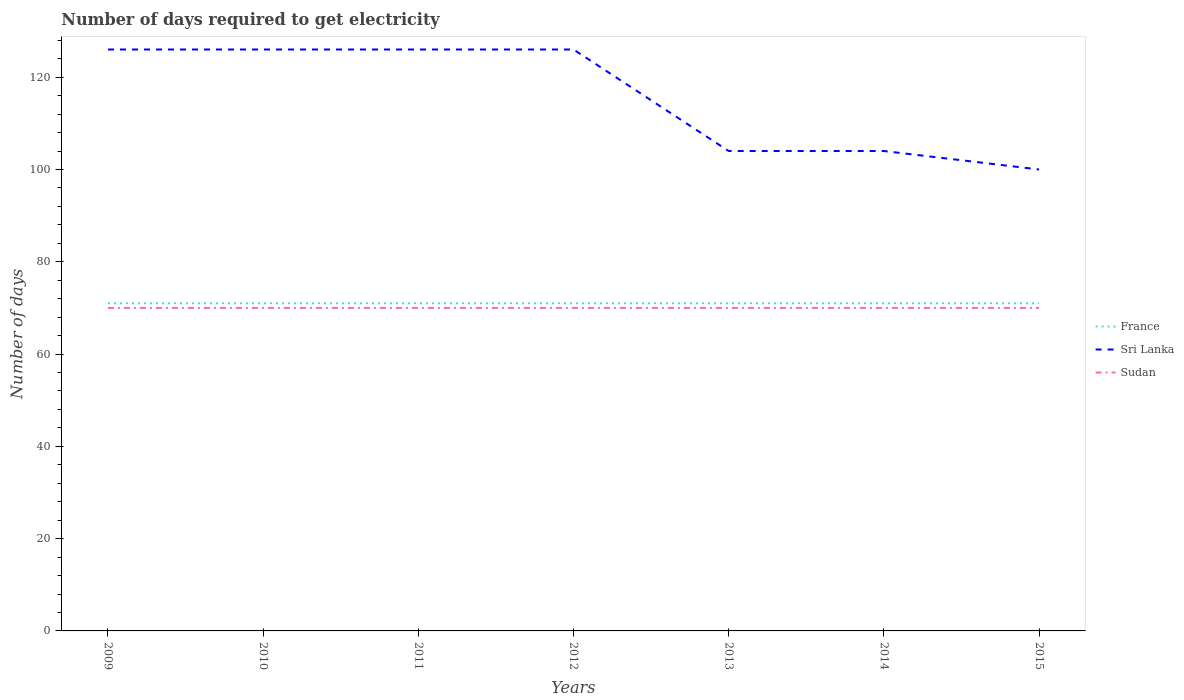How many different coloured lines are there?
Offer a very short reply. 3. Is the number of lines equal to the number of legend labels?
Your response must be concise. Yes. Across all years, what is the maximum number of days required to get electricity in in Sudan?
Your answer should be compact. 70. In which year was the number of days required to get electricity in in France maximum?
Provide a succinct answer. 2009. What is the total number of days required to get electricity in in Sri Lanka in the graph?
Give a very brief answer. 26. How many lines are there?
Offer a very short reply. 3. How many years are there in the graph?
Make the answer very short. 7. How many legend labels are there?
Provide a short and direct response. 3. What is the title of the graph?
Your answer should be compact. Number of days required to get electricity. Does "Bosnia and Herzegovina" appear as one of the legend labels in the graph?
Provide a short and direct response. No. What is the label or title of the Y-axis?
Make the answer very short. Number of days. What is the Number of days in France in 2009?
Your response must be concise. 71. What is the Number of days in Sri Lanka in 2009?
Your answer should be compact. 126. What is the Number of days in France in 2010?
Keep it short and to the point. 71. What is the Number of days of Sri Lanka in 2010?
Give a very brief answer. 126. What is the Number of days in Sudan in 2010?
Make the answer very short. 70. What is the Number of days in Sri Lanka in 2011?
Provide a short and direct response. 126. What is the Number of days of Sri Lanka in 2012?
Your answer should be compact. 126. What is the Number of days in Sudan in 2012?
Offer a terse response. 70. What is the Number of days in Sri Lanka in 2013?
Offer a terse response. 104. What is the Number of days in Sudan in 2013?
Offer a very short reply. 70. What is the Number of days in Sri Lanka in 2014?
Make the answer very short. 104. What is the Number of days in Sudan in 2014?
Your answer should be very brief. 70. What is the Number of days of Sri Lanka in 2015?
Your answer should be very brief. 100. Across all years, what is the maximum Number of days of France?
Your response must be concise. 71. Across all years, what is the maximum Number of days in Sri Lanka?
Provide a succinct answer. 126. Across all years, what is the minimum Number of days in France?
Provide a short and direct response. 71. What is the total Number of days in France in the graph?
Provide a succinct answer. 497. What is the total Number of days in Sri Lanka in the graph?
Provide a succinct answer. 812. What is the total Number of days in Sudan in the graph?
Provide a short and direct response. 490. What is the difference between the Number of days of Sri Lanka in 2009 and that in 2010?
Your answer should be very brief. 0. What is the difference between the Number of days in France in 2009 and that in 2011?
Offer a terse response. 0. What is the difference between the Number of days of Sri Lanka in 2009 and that in 2011?
Your response must be concise. 0. What is the difference between the Number of days of Sudan in 2009 and that in 2012?
Your answer should be compact. 0. What is the difference between the Number of days in France in 2009 and that in 2013?
Make the answer very short. 0. What is the difference between the Number of days in Sudan in 2009 and that in 2013?
Your response must be concise. 0. What is the difference between the Number of days of France in 2009 and that in 2014?
Provide a short and direct response. 0. What is the difference between the Number of days of Sri Lanka in 2009 and that in 2014?
Your response must be concise. 22. What is the difference between the Number of days in Sudan in 2009 and that in 2014?
Provide a succinct answer. 0. What is the difference between the Number of days of Sri Lanka in 2009 and that in 2015?
Offer a very short reply. 26. What is the difference between the Number of days of France in 2010 and that in 2011?
Make the answer very short. 0. What is the difference between the Number of days in France in 2010 and that in 2013?
Provide a succinct answer. 0. What is the difference between the Number of days of Sri Lanka in 2010 and that in 2013?
Give a very brief answer. 22. What is the difference between the Number of days of Sri Lanka in 2010 and that in 2014?
Make the answer very short. 22. What is the difference between the Number of days in France in 2010 and that in 2015?
Your answer should be very brief. 0. What is the difference between the Number of days in Sudan in 2010 and that in 2015?
Your answer should be very brief. 0. What is the difference between the Number of days in France in 2011 and that in 2012?
Your response must be concise. 0. What is the difference between the Number of days of Sudan in 2011 and that in 2012?
Your answer should be compact. 0. What is the difference between the Number of days in France in 2011 and that in 2014?
Provide a short and direct response. 0. What is the difference between the Number of days of Sri Lanka in 2011 and that in 2015?
Your answer should be very brief. 26. What is the difference between the Number of days of France in 2013 and that in 2014?
Ensure brevity in your answer.  0. What is the difference between the Number of days in Sri Lanka in 2013 and that in 2015?
Provide a short and direct response. 4. What is the difference between the Number of days of Sri Lanka in 2014 and that in 2015?
Give a very brief answer. 4. What is the difference between the Number of days in Sudan in 2014 and that in 2015?
Keep it short and to the point. 0. What is the difference between the Number of days of France in 2009 and the Number of days of Sri Lanka in 2010?
Give a very brief answer. -55. What is the difference between the Number of days of Sri Lanka in 2009 and the Number of days of Sudan in 2010?
Your answer should be compact. 56. What is the difference between the Number of days of France in 2009 and the Number of days of Sri Lanka in 2011?
Give a very brief answer. -55. What is the difference between the Number of days in France in 2009 and the Number of days in Sudan in 2011?
Provide a short and direct response. 1. What is the difference between the Number of days of Sri Lanka in 2009 and the Number of days of Sudan in 2011?
Provide a short and direct response. 56. What is the difference between the Number of days of France in 2009 and the Number of days of Sri Lanka in 2012?
Keep it short and to the point. -55. What is the difference between the Number of days of Sri Lanka in 2009 and the Number of days of Sudan in 2012?
Provide a short and direct response. 56. What is the difference between the Number of days of France in 2009 and the Number of days of Sri Lanka in 2013?
Offer a terse response. -33. What is the difference between the Number of days in France in 2009 and the Number of days in Sudan in 2013?
Offer a very short reply. 1. What is the difference between the Number of days in Sri Lanka in 2009 and the Number of days in Sudan in 2013?
Your answer should be compact. 56. What is the difference between the Number of days of France in 2009 and the Number of days of Sri Lanka in 2014?
Offer a very short reply. -33. What is the difference between the Number of days in France in 2009 and the Number of days in Sudan in 2014?
Ensure brevity in your answer.  1. What is the difference between the Number of days of Sri Lanka in 2009 and the Number of days of Sudan in 2014?
Your answer should be very brief. 56. What is the difference between the Number of days of France in 2009 and the Number of days of Sri Lanka in 2015?
Provide a short and direct response. -29. What is the difference between the Number of days of France in 2010 and the Number of days of Sri Lanka in 2011?
Give a very brief answer. -55. What is the difference between the Number of days of France in 2010 and the Number of days of Sri Lanka in 2012?
Give a very brief answer. -55. What is the difference between the Number of days of France in 2010 and the Number of days of Sudan in 2012?
Provide a short and direct response. 1. What is the difference between the Number of days in Sri Lanka in 2010 and the Number of days in Sudan in 2012?
Provide a short and direct response. 56. What is the difference between the Number of days of France in 2010 and the Number of days of Sri Lanka in 2013?
Ensure brevity in your answer.  -33. What is the difference between the Number of days of France in 2010 and the Number of days of Sudan in 2013?
Offer a terse response. 1. What is the difference between the Number of days in France in 2010 and the Number of days in Sri Lanka in 2014?
Provide a succinct answer. -33. What is the difference between the Number of days in France in 2010 and the Number of days in Sudan in 2014?
Your answer should be very brief. 1. What is the difference between the Number of days in Sri Lanka in 2010 and the Number of days in Sudan in 2014?
Your answer should be compact. 56. What is the difference between the Number of days of France in 2010 and the Number of days of Sudan in 2015?
Provide a short and direct response. 1. What is the difference between the Number of days of France in 2011 and the Number of days of Sri Lanka in 2012?
Your answer should be very brief. -55. What is the difference between the Number of days in France in 2011 and the Number of days in Sudan in 2012?
Offer a terse response. 1. What is the difference between the Number of days in France in 2011 and the Number of days in Sri Lanka in 2013?
Give a very brief answer. -33. What is the difference between the Number of days in France in 2011 and the Number of days in Sri Lanka in 2014?
Ensure brevity in your answer.  -33. What is the difference between the Number of days in France in 2011 and the Number of days in Sudan in 2014?
Your response must be concise. 1. What is the difference between the Number of days of France in 2012 and the Number of days of Sri Lanka in 2013?
Make the answer very short. -33. What is the difference between the Number of days of France in 2012 and the Number of days of Sri Lanka in 2014?
Make the answer very short. -33. What is the difference between the Number of days of France in 2012 and the Number of days of Sudan in 2014?
Your answer should be very brief. 1. What is the difference between the Number of days in France in 2012 and the Number of days in Sri Lanka in 2015?
Provide a short and direct response. -29. What is the difference between the Number of days in France in 2012 and the Number of days in Sudan in 2015?
Your response must be concise. 1. What is the difference between the Number of days of France in 2013 and the Number of days of Sri Lanka in 2014?
Provide a short and direct response. -33. What is the difference between the Number of days of Sri Lanka in 2013 and the Number of days of Sudan in 2014?
Offer a terse response. 34. What is the difference between the Number of days in France in 2013 and the Number of days in Sri Lanka in 2015?
Offer a very short reply. -29. What is the difference between the Number of days of France in 2013 and the Number of days of Sudan in 2015?
Offer a very short reply. 1. What is the difference between the Number of days of Sri Lanka in 2013 and the Number of days of Sudan in 2015?
Provide a short and direct response. 34. What is the difference between the Number of days in France in 2014 and the Number of days in Sri Lanka in 2015?
Offer a very short reply. -29. What is the difference between the Number of days in Sri Lanka in 2014 and the Number of days in Sudan in 2015?
Offer a terse response. 34. What is the average Number of days of France per year?
Your answer should be very brief. 71. What is the average Number of days in Sri Lanka per year?
Your answer should be compact. 116. What is the average Number of days in Sudan per year?
Provide a succinct answer. 70. In the year 2009, what is the difference between the Number of days in France and Number of days in Sri Lanka?
Provide a succinct answer. -55. In the year 2009, what is the difference between the Number of days of France and Number of days of Sudan?
Offer a very short reply. 1. In the year 2010, what is the difference between the Number of days of France and Number of days of Sri Lanka?
Provide a short and direct response. -55. In the year 2010, what is the difference between the Number of days in France and Number of days in Sudan?
Give a very brief answer. 1. In the year 2010, what is the difference between the Number of days in Sri Lanka and Number of days in Sudan?
Give a very brief answer. 56. In the year 2011, what is the difference between the Number of days of France and Number of days of Sri Lanka?
Give a very brief answer. -55. In the year 2011, what is the difference between the Number of days of France and Number of days of Sudan?
Your response must be concise. 1. In the year 2011, what is the difference between the Number of days of Sri Lanka and Number of days of Sudan?
Give a very brief answer. 56. In the year 2012, what is the difference between the Number of days in France and Number of days in Sri Lanka?
Your response must be concise. -55. In the year 2012, what is the difference between the Number of days of France and Number of days of Sudan?
Your answer should be compact. 1. In the year 2012, what is the difference between the Number of days of Sri Lanka and Number of days of Sudan?
Provide a succinct answer. 56. In the year 2013, what is the difference between the Number of days in France and Number of days in Sri Lanka?
Make the answer very short. -33. In the year 2014, what is the difference between the Number of days of France and Number of days of Sri Lanka?
Your answer should be very brief. -33. In the year 2014, what is the difference between the Number of days in Sri Lanka and Number of days in Sudan?
Your answer should be compact. 34. In the year 2015, what is the difference between the Number of days of France and Number of days of Sri Lanka?
Make the answer very short. -29. In the year 2015, what is the difference between the Number of days of France and Number of days of Sudan?
Give a very brief answer. 1. In the year 2015, what is the difference between the Number of days in Sri Lanka and Number of days in Sudan?
Your answer should be compact. 30. What is the ratio of the Number of days of Sri Lanka in 2009 to that in 2010?
Keep it short and to the point. 1. What is the ratio of the Number of days of Sudan in 2009 to that in 2010?
Keep it short and to the point. 1. What is the ratio of the Number of days of France in 2009 to that in 2011?
Keep it short and to the point. 1. What is the ratio of the Number of days in Sudan in 2009 to that in 2011?
Give a very brief answer. 1. What is the ratio of the Number of days in France in 2009 to that in 2013?
Your answer should be compact. 1. What is the ratio of the Number of days of Sri Lanka in 2009 to that in 2013?
Offer a very short reply. 1.21. What is the ratio of the Number of days in Sudan in 2009 to that in 2013?
Provide a succinct answer. 1. What is the ratio of the Number of days of France in 2009 to that in 2014?
Your answer should be very brief. 1. What is the ratio of the Number of days of Sri Lanka in 2009 to that in 2014?
Provide a short and direct response. 1.21. What is the ratio of the Number of days of Sri Lanka in 2009 to that in 2015?
Ensure brevity in your answer.  1.26. What is the ratio of the Number of days of Sudan in 2009 to that in 2015?
Ensure brevity in your answer.  1. What is the ratio of the Number of days of Sri Lanka in 2010 to that in 2011?
Keep it short and to the point. 1. What is the ratio of the Number of days of France in 2010 to that in 2012?
Make the answer very short. 1. What is the ratio of the Number of days of Sri Lanka in 2010 to that in 2013?
Your answer should be compact. 1.21. What is the ratio of the Number of days of Sudan in 2010 to that in 2013?
Offer a terse response. 1. What is the ratio of the Number of days of France in 2010 to that in 2014?
Keep it short and to the point. 1. What is the ratio of the Number of days of Sri Lanka in 2010 to that in 2014?
Your answer should be compact. 1.21. What is the ratio of the Number of days in Sudan in 2010 to that in 2014?
Give a very brief answer. 1. What is the ratio of the Number of days in Sri Lanka in 2010 to that in 2015?
Provide a succinct answer. 1.26. What is the ratio of the Number of days in France in 2011 to that in 2012?
Ensure brevity in your answer.  1. What is the ratio of the Number of days in Sri Lanka in 2011 to that in 2012?
Provide a short and direct response. 1. What is the ratio of the Number of days in Sudan in 2011 to that in 2012?
Offer a terse response. 1. What is the ratio of the Number of days of Sri Lanka in 2011 to that in 2013?
Provide a succinct answer. 1.21. What is the ratio of the Number of days in Sudan in 2011 to that in 2013?
Ensure brevity in your answer.  1. What is the ratio of the Number of days in France in 2011 to that in 2014?
Provide a short and direct response. 1. What is the ratio of the Number of days in Sri Lanka in 2011 to that in 2014?
Give a very brief answer. 1.21. What is the ratio of the Number of days in Sudan in 2011 to that in 2014?
Provide a short and direct response. 1. What is the ratio of the Number of days of Sri Lanka in 2011 to that in 2015?
Your answer should be very brief. 1.26. What is the ratio of the Number of days in Sudan in 2011 to that in 2015?
Your answer should be compact. 1. What is the ratio of the Number of days in France in 2012 to that in 2013?
Offer a very short reply. 1. What is the ratio of the Number of days in Sri Lanka in 2012 to that in 2013?
Offer a terse response. 1.21. What is the ratio of the Number of days of France in 2012 to that in 2014?
Provide a short and direct response. 1. What is the ratio of the Number of days of Sri Lanka in 2012 to that in 2014?
Your response must be concise. 1.21. What is the ratio of the Number of days of Sudan in 2012 to that in 2014?
Give a very brief answer. 1. What is the ratio of the Number of days of France in 2012 to that in 2015?
Make the answer very short. 1. What is the ratio of the Number of days in Sri Lanka in 2012 to that in 2015?
Provide a short and direct response. 1.26. What is the ratio of the Number of days of Sudan in 2012 to that in 2015?
Ensure brevity in your answer.  1. What is the ratio of the Number of days of France in 2013 to that in 2014?
Your answer should be compact. 1. What is the ratio of the Number of days of Sri Lanka in 2013 to that in 2014?
Offer a terse response. 1. What is the difference between the highest and the second highest Number of days of Sri Lanka?
Give a very brief answer. 0. What is the difference between the highest and the second highest Number of days in Sudan?
Offer a terse response. 0. 